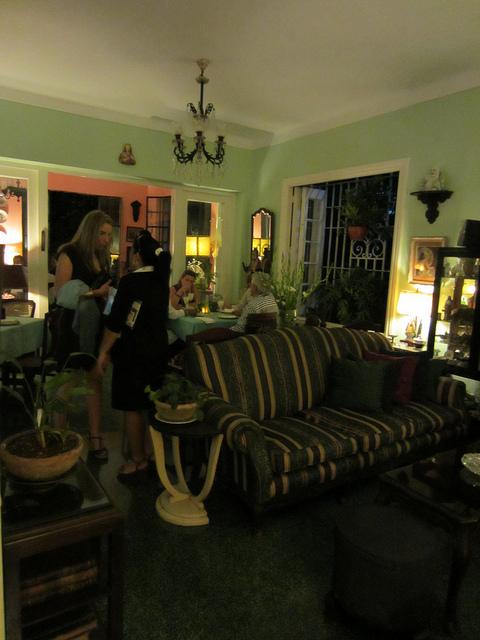Is it day or night?
Quick response, please. Night. Is the couch stupid?
Keep it brief. No. What color are the walls?
Keep it brief. Green. 